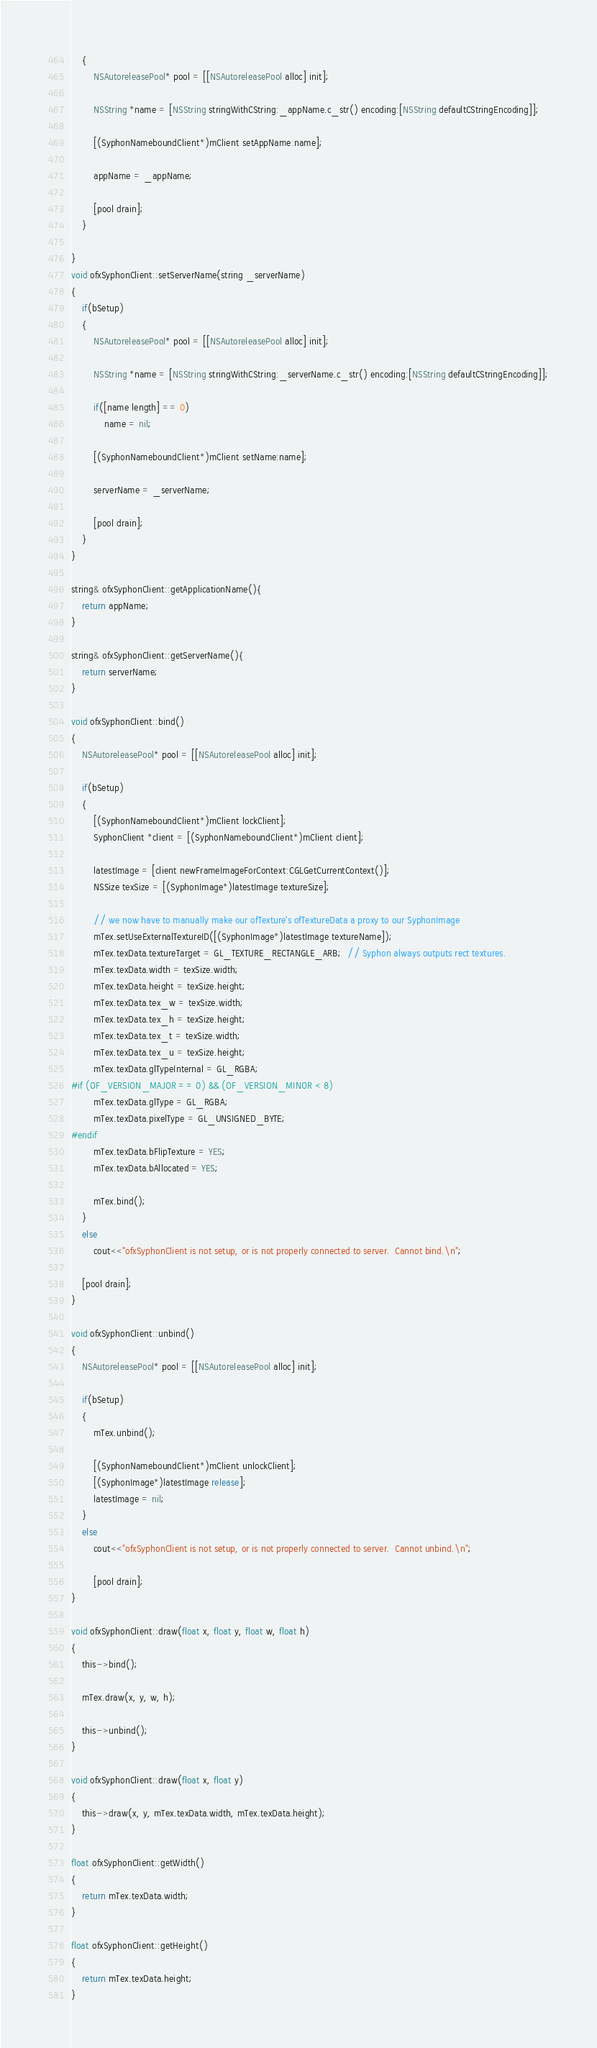<code> <loc_0><loc_0><loc_500><loc_500><_ObjectiveC_>    {
        NSAutoreleasePool* pool = [[NSAutoreleasePool alloc] init];
        
        NSString *name = [NSString stringWithCString:_appName.c_str() encoding:[NSString defaultCStringEncoding]];
        
        [(SyphonNameboundClient*)mClient setAppName:name];
        
        appName = _appName;

        [pool drain];
    }
    
}
void ofxSyphonClient::setServerName(string _serverName)
{
    if(bSetup)
    {
        NSAutoreleasePool* pool = [[NSAutoreleasePool alloc] init];
        
        NSString *name = [NSString stringWithCString:_serverName.c_str() encoding:[NSString defaultCStringEncoding]];

        if([name length] == 0)
            name = nil;
        
        [(SyphonNameboundClient*)mClient setName:name];
        
        serverName = _serverName;
    
        [pool drain];
    }    
}

string& ofxSyphonClient::getApplicationName(){
    return appName;
}

string& ofxSyphonClient::getServerName(){
    return serverName;
}

void ofxSyphonClient::bind()
{
    NSAutoreleasePool* pool = [[NSAutoreleasePool alloc] init];
    
    if(bSetup)
    {
     	[(SyphonNameboundClient*)mClient lockClient];
        SyphonClient *client = [(SyphonNameboundClient*)mClient client];
        
        latestImage = [client newFrameImageForContext:CGLGetCurrentContext()];
		NSSize texSize = [(SyphonImage*)latestImage textureSize];
        
        // we now have to manually make our ofTexture's ofTextureData a proxy to our SyphonImage
        mTex.setUseExternalTextureID([(SyphonImage*)latestImage textureName]);
        mTex.texData.textureTarget = GL_TEXTURE_RECTANGLE_ARB;  // Syphon always outputs rect textures.
        mTex.texData.width = texSize.width;
        mTex.texData.height = texSize.height;
        mTex.texData.tex_w = texSize.width;
        mTex.texData.tex_h = texSize.height;
        mTex.texData.tex_t = texSize.width;
        mTex.texData.tex_u = texSize.height;
        mTex.texData.glTypeInternal = GL_RGBA;
#if (OF_VERSION_MAJOR == 0) && (OF_VERSION_MINOR < 8)
        mTex.texData.glType = GL_RGBA;
        mTex.texData.pixelType = GL_UNSIGNED_BYTE;
#endif
        mTex.texData.bFlipTexture = YES;
        mTex.texData.bAllocated = YES;
        
        mTex.bind();
    }
    else
		cout<<"ofxSyphonClient is not setup, or is not properly connected to server.  Cannot bind.\n";
    
    [pool drain];
}

void ofxSyphonClient::unbind()
{
    NSAutoreleasePool* pool = [[NSAutoreleasePool alloc] init];
    
    if(bSetup)
    {
        mTex.unbind();

        [(SyphonNameboundClient*)mClient unlockClient];
        [(SyphonImage*)latestImage release];
        latestImage = nil;
    }
    else
		cout<<"ofxSyphonClient is not setup, or is not properly connected to server.  Cannot unbind.\n";

        [pool drain];
}

void ofxSyphonClient::draw(float x, float y, float w, float h)
{
    this->bind();
    
    mTex.draw(x, y, w, h);
    
    this->unbind();
}

void ofxSyphonClient::draw(float x, float y)
{
	this->draw(x, y, mTex.texData.width, mTex.texData.height);
}

float ofxSyphonClient::getWidth()
{
	return mTex.texData.width;
}

float ofxSyphonClient::getHeight()
{
	return mTex.texData.height;
}


</code> 